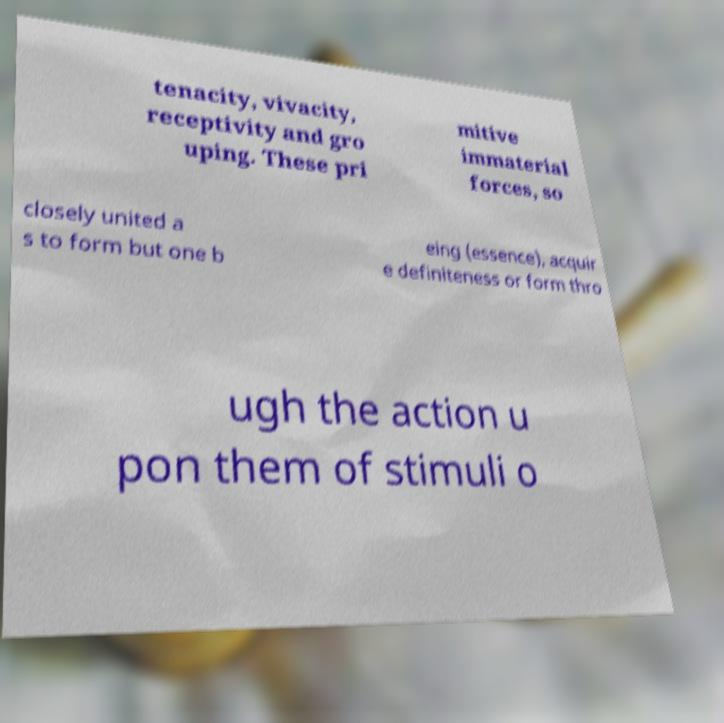I need the written content from this picture converted into text. Can you do that? tenacity, vivacity, receptivity and gro uping. These pri mitive immaterial forces, so closely united a s to form but one b eing (essence), acquir e definiteness or form thro ugh the action u pon them of stimuli o 